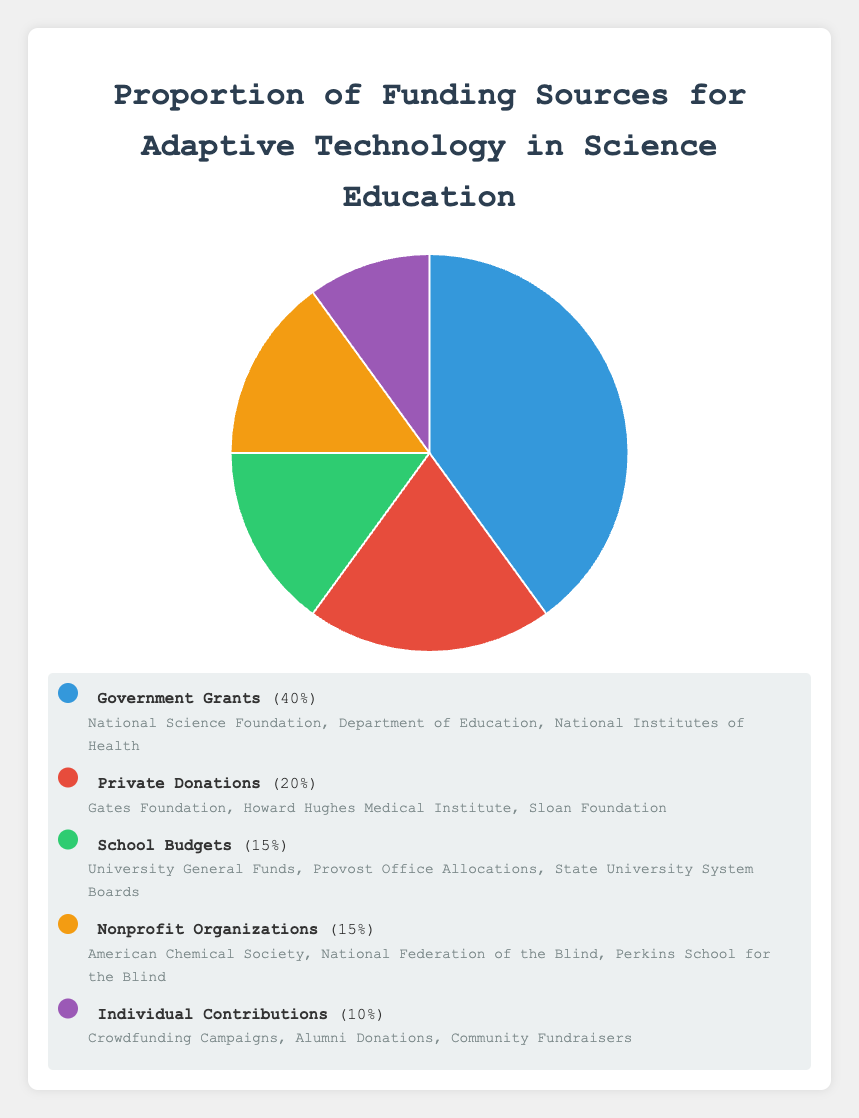What is the largest source of funding as a percentage? The largest source of funding is the one with the highest proportion. From the data, Government Grants have the highest proportion of 40%.
Answer: Government Grants What is the combined funding percentage from Private Donations and Individual Contributions? To find the combined percentage, add the proportions of Private Donations (20%) and Individual Contributions (10%). 20% + 10% = 30%.
Answer: 30% Which funding source provides an equal percentage share to School Budgets? School Budgets have a proportion of 15%. Nonprofit Organizations also have a proportion of 15%, making them equal.
Answer: Nonprofit Organizations How much more funding do Government Grants provide compared to School Budgets? Subtract the proportion of School Budgets (15%) from the proportion of Government Grants (40%). 40% - 15% = 25%.
Answer: 25% What are the entities involved in the funding provided by Nonprofit Organizations? According to the data, the entities under Nonprofit Organizations are the American Chemical Society, National Federation of the Blind, and Perkins School for the Blind.
Answer: American Chemical Society, National Federation of the Blind, Perkins School for the Blind Which funding source has the smallest percentage share? The funding source with the lowest proportion is Individual Contributions, which has a 10% share.
Answer: Individual Contributions What is the average funding percentage among all sources? To find the average percentage, add up all the proportions (40% + 20% + 15% + 15% + 10% = 100%) and divide by the number of sources (5). 100% / 5 = 20%.
Answer: 20% Between Private Donations and Nonprofit Organizations, which provides more funding and by how much? Private Donations provide 20% and Nonprofit Organizations provide 15%. Subtract the smaller proportion from the larger one. 20% - 15% = 5%.
Answer: Private Donations by 5% What color represents the funding from School Budgets in the chart? According to the visual setup, the color corresponding to School Budgets needs to be described. Based on the color order generally used, School Budgets are typically the third in the list.
Answer: Green (assuming a typical color order) 